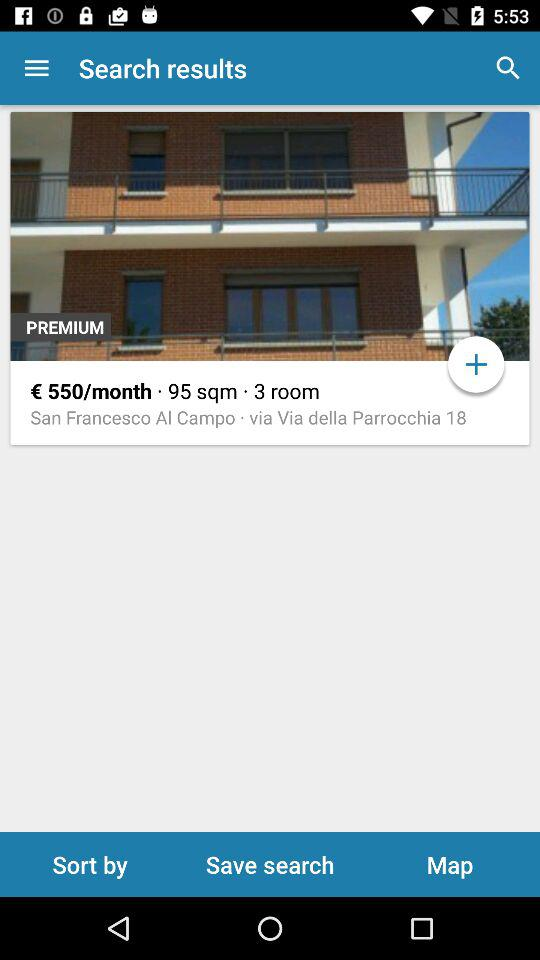What is the price? The price is €550 per month. 